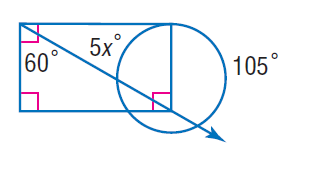Question: Find x. Assume that any segment that appears to be tangent is tangent.
Choices:
A. 9
B. 45
C. 60
D. 105
Answer with the letter. Answer: A 